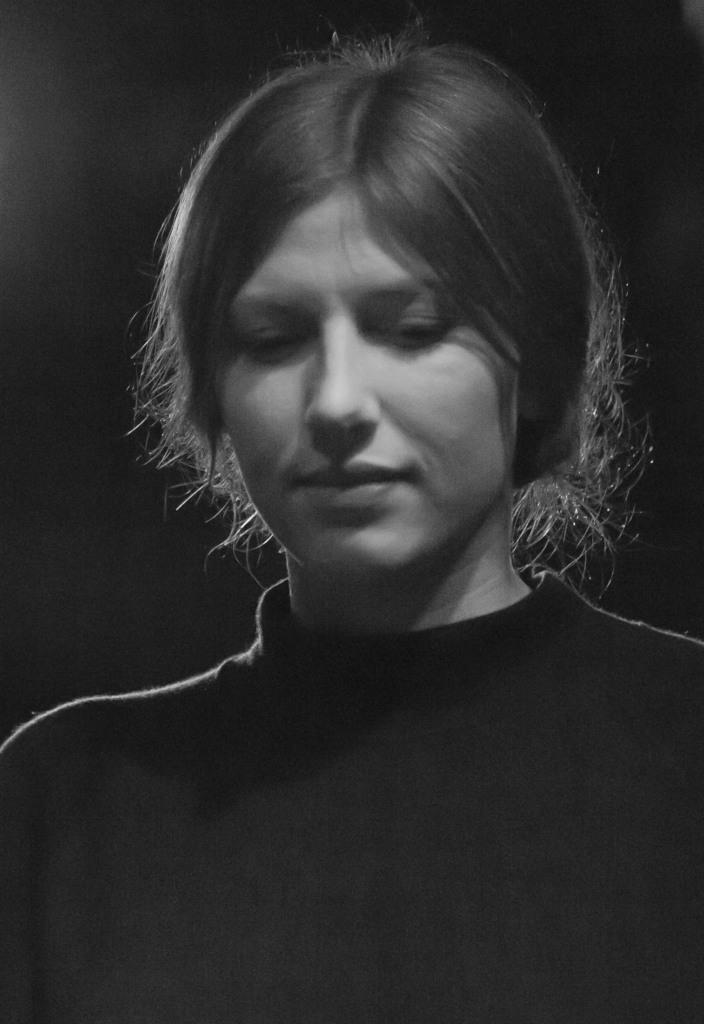Who is present in the image? There is a woman in the image. What can be observed about the background of the image? The background of the image is dark. What type of dock can be seen in the image? There is no dock present in the image. How many clovers are visible in the image? There are no clovers visible in the image. 